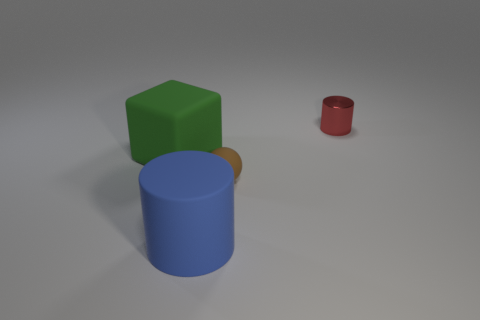Add 3 tiny gray matte spheres. How many objects exist? 7 Subtract all blocks. How many objects are left? 3 Subtract 1 cubes. How many cubes are left? 0 Subtract all cyan blocks. Subtract all cyan spheres. How many blocks are left? 1 Subtract all yellow shiny cylinders. Subtract all blue rubber objects. How many objects are left? 3 Add 4 big cylinders. How many big cylinders are left? 5 Add 2 small green blocks. How many small green blocks exist? 2 Subtract 0 purple blocks. How many objects are left? 4 